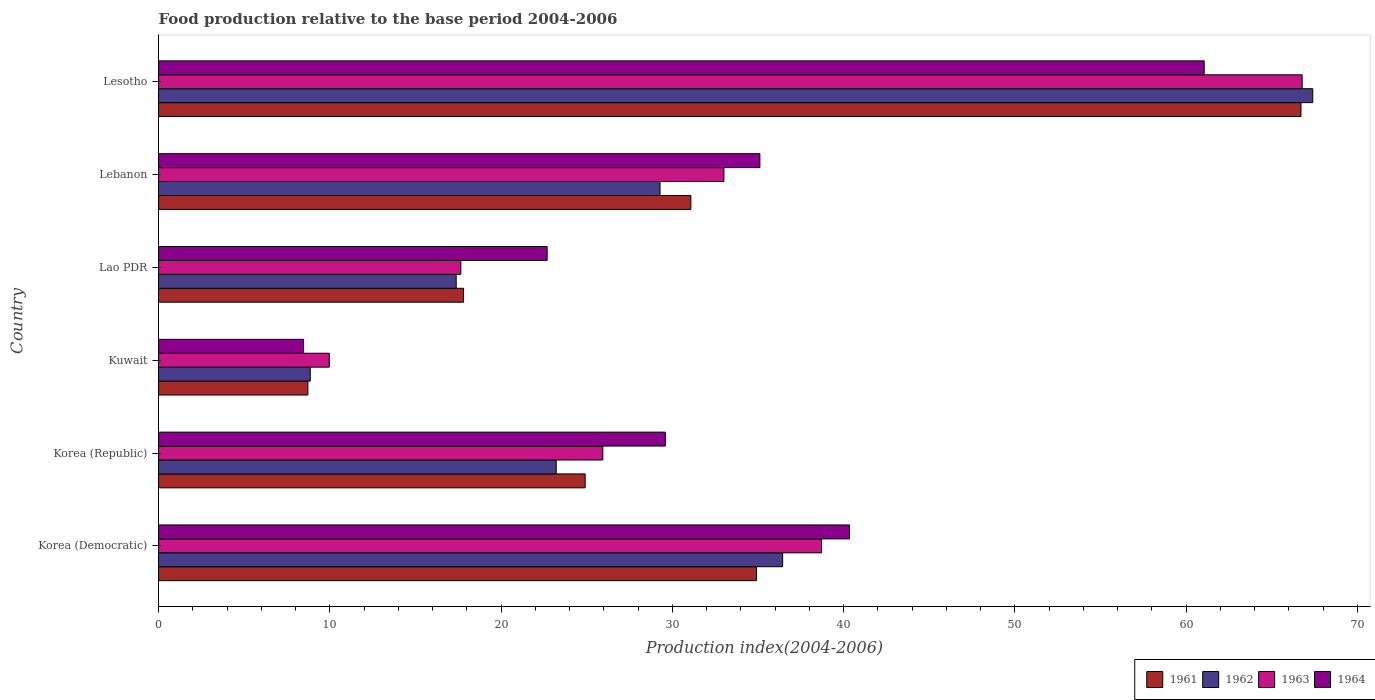How many different coloured bars are there?
Offer a very short reply. 4. How many groups of bars are there?
Your response must be concise. 6. Are the number of bars on each tick of the Y-axis equal?
Give a very brief answer. Yes. What is the label of the 6th group of bars from the top?
Keep it short and to the point. Korea (Democratic). In how many cases, is the number of bars for a given country not equal to the number of legend labels?
Give a very brief answer. 0. What is the food production index in 1962 in Korea (Democratic)?
Keep it short and to the point. 36.44. Across all countries, what is the maximum food production index in 1962?
Provide a succinct answer. 67.39. Across all countries, what is the minimum food production index in 1961?
Provide a short and direct response. 8.72. In which country was the food production index in 1961 maximum?
Give a very brief answer. Lesotho. In which country was the food production index in 1964 minimum?
Your answer should be very brief. Kuwait. What is the total food production index in 1962 in the graph?
Your response must be concise. 182.57. What is the difference between the food production index in 1961 in Korea (Democratic) and that in Lebanon?
Ensure brevity in your answer.  3.83. What is the difference between the food production index in 1963 in Lebanon and the food production index in 1962 in Korea (Republic)?
Your response must be concise. 9.79. What is the average food production index in 1962 per country?
Offer a very short reply. 30.43. What is the difference between the food production index in 1964 and food production index in 1961 in Korea (Democratic)?
Your answer should be compact. 5.43. In how many countries, is the food production index in 1964 greater than 40 ?
Your answer should be very brief. 2. What is the ratio of the food production index in 1961 in Korea (Democratic) to that in Lebanon?
Make the answer very short. 1.12. Is the food production index in 1961 in Korea (Democratic) less than that in Kuwait?
Provide a succinct answer. No. Is the difference between the food production index in 1964 in Korea (Democratic) and Kuwait greater than the difference between the food production index in 1961 in Korea (Democratic) and Kuwait?
Keep it short and to the point. Yes. What is the difference between the highest and the second highest food production index in 1962?
Your answer should be very brief. 30.95. What is the difference between the highest and the lowest food production index in 1964?
Your answer should be very brief. 52.58. Is the sum of the food production index in 1962 in Korea (Democratic) and Kuwait greater than the maximum food production index in 1961 across all countries?
Keep it short and to the point. No. Is it the case that in every country, the sum of the food production index in 1963 and food production index in 1961 is greater than the sum of food production index in 1962 and food production index in 1964?
Provide a succinct answer. No. What does the 3rd bar from the top in Lao PDR represents?
Your answer should be very brief. 1962. What does the 1st bar from the bottom in Korea (Democratic) represents?
Your answer should be compact. 1961. How many bars are there?
Provide a short and direct response. 24. Are all the bars in the graph horizontal?
Offer a terse response. Yes. Are the values on the major ticks of X-axis written in scientific E-notation?
Your answer should be compact. No. Does the graph contain any zero values?
Make the answer very short. No. Where does the legend appear in the graph?
Keep it short and to the point. Bottom right. How are the legend labels stacked?
Keep it short and to the point. Horizontal. What is the title of the graph?
Offer a terse response. Food production relative to the base period 2004-2006. Does "1997" appear as one of the legend labels in the graph?
Your answer should be compact. No. What is the label or title of the X-axis?
Give a very brief answer. Production index(2004-2006). What is the Production index(2004-2006) of 1961 in Korea (Democratic)?
Your response must be concise. 34.91. What is the Production index(2004-2006) in 1962 in Korea (Democratic)?
Your answer should be compact. 36.44. What is the Production index(2004-2006) in 1963 in Korea (Democratic)?
Offer a terse response. 38.71. What is the Production index(2004-2006) of 1964 in Korea (Democratic)?
Your response must be concise. 40.34. What is the Production index(2004-2006) of 1961 in Korea (Republic)?
Your answer should be very brief. 24.91. What is the Production index(2004-2006) in 1962 in Korea (Republic)?
Your response must be concise. 23.22. What is the Production index(2004-2006) of 1963 in Korea (Republic)?
Provide a succinct answer. 25.94. What is the Production index(2004-2006) in 1964 in Korea (Republic)?
Offer a terse response. 29.59. What is the Production index(2004-2006) in 1961 in Kuwait?
Your answer should be very brief. 8.72. What is the Production index(2004-2006) of 1962 in Kuwait?
Provide a short and direct response. 8.86. What is the Production index(2004-2006) of 1963 in Kuwait?
Make the answer very short. 9.97. What is the Production index(2004-2006) in 1964 in Kuwait?
Your answer should be very brief. 8.47. What is the Production index(2004-2006) of 1961 in Lao PDR?
Ensure brevity in your answer.  17.81. What is the Production index(2004-2006) in 1962 in Lao PDR?
Offer a very short reply. 17.38. What is the Production index(2004-2006) of 1963 in Lao PDR?
Offer a very short reply. 17.65. What is the Production index(2004-2006) of 1964 in Lao PDR?
Make the answer very short. 22.69. What is the Production index(2004-2006) in 1961 in Lebanon?
Make the answer very short. 31.08. What is the Production index(2004-2006) of 1962 in Lebanon?
Your answer should be very brief. 29.28. What is the Production index(2004-2006) in 1963 in Lebanon?
Ensure brevity in your answer.  33.01. What is the Production index(2004-2006) of 1964 in Lebanon?
Your answer should be compact. 35.11. What is the Production index(2004-2006) in 1961 in Lesotho?
Ensure brevity in your answer.  66.7. What is the Production index(2004-2006) in 1962 in Lesotho?
Your response must be concise. 67.39. What is the Production index(2004-2006) of 1963 in Lesotho?
Your response must be concise. 66.77. What is the Production index(2004-2006) of 1964 in Lesotho?
Provide a succinct answer. 61.05. Across all countries, what is the maximum Production index(2004-2006) of 1961?
Your answer should be very brief. 66.7. Across all countries, what is the maximum Production index(2004-2006) in 1962?
Make the answer very short. 67.39. Across all countries, what is the maximum Production index(2004-2006) in 1963?
Make the answer very short. 66.77. Across all countries, what is the maximum Production index(2004-2006) in 1964?
Offer a terse response. 61.05. Across all countries, what is the minimum Production index(2004-2006) in 1961?
Your response must be concise. 8.72. Across all countries, what is the minimum Production index(2004-2006) in 1962?
Offer a terse response. 8.86. Across all countries, what is the minimum Production index(2004-2006) in 1963?
Offer a very short reply. 9.97. Across all countries, what is the minimum Production index(2004-2006) in 1964?
Keep it short and to the point. 8.47. What is the total Production index(2004-2006) in 1961 in the graph?
Ensure brevity in your answer.  184.13. What is the total Production index(2004-2006) of 1962 in the graph?
Give a very brief answer. 182.57. What is the total Production index(2004-2006) in 1963 in the graph?
Ensure brevity in your answer.  192.05. What is the total Production index(2004-2006) in 1964 in the graph?
Give a very brief answer. 197.25. What is the difference between the Production index(2004-2006) of 1962 in Korea (Democratic) and that in Korea (Republic)?
Offer a terse response. 13.22. What is the difference between the Production index(2004-2006) in 1963 in Korea (Democratic) and that in Korea (Republic)?
Your answer should be compact. 12.77. What is the difference between the Production index(2004-2006) of 1964 in Korea (Democratic) and that in Korea (Republic)?
Make the answer very short. 10.75. What is the difference between the Production index(2004-2006) of 1961 in Korea (Democratic) and that in Kuwait?
Make the answer very short. 26.19. What is the difference between the Production index(2004-2006) of 1962 in Korea (Democratic) and that in Kuwait?
Keep it short and to the point. 27.58. What is the difference between the Production index(2004-2006) in 1963 in Korea (Democratic) and that in Kuwait?
Your response must be concise. 28.74. What is the difference between the Production index(2004-2006) of 1964 in Korea (Democratic) and that in Kuwait?
Offer a terse response. 31.87. What is the difference between the Production index(2004-2006) in 1962 in Korea (Democratic) and that in Lao PDR?
Offer a very short reply. 19.06. What is the difference between the Production index(2004-2006) in 1963 in Korea (Democratic) and that in Lao PDR?
Offer a terse response. 21.06. What is the difference between the Production index(2004-2006) of 1964 in Korea (Democratic) and that in Lao PDR?
Your response must be concise. 17.65. What is the difference between the Production index(2004-2006) of 1961 in Korea (Democratic) and that in Lebanon?
Provide a succinct answer. 3.83. What is the difference between the Production index(2004-2006) in 1962 in Korea (Democratic) and that in Lebanon?
Offer a very short reply. 7.16. What is the difference between the Production index(2004-2006) of 1963 in Korea (Democratic) and that in Lebanon?
Your answer should be very brief. 5.7. What is the difference between the Production index(2004-2006) in 1964 in Korea (Democratic) and that in Lebanon?
Offer a terse response. 5.23. What is the difference between the Production index(2004-2006) in 1961 in Korea (Democratic) and that in Lesotho?
Your answer should be compact. -31.79. What is the difference between the Production index(2004-2006) in 1962 in Korea (Democratic) and that in Lesotho?
Offer a terse response. -30.95. What is the difference between the Production index(2004-2006) in 1963 in Korea (Democratic) and that in Lesotho?
Offer a terse response. -28.06. What is the difference between the Production index(2004-2006) in 1964 in Korea (Democratic) and that in Lesotho?
Ensure brevity in your answer.  -20.71. What is the difference between the Production index(2004-2006) in 1961 in Korea (Republic) and that in Kuwait?
Offer a terse response. 16.19. What is the difference between the Production index(2004-2006) of 1962 in Korea (Republic) and that in Kuwait?
Ensure brevity in your answer.  14.36. What is the difference between the Production index(2004-2006) of 1963 in Korea (Republic) and that in Kuwait?
Make the answer very short. 15.97. What is the difference between the Production index(2004-2006) of 1964 in Korea (Republic) and that in Kuwait?
Your answer should be compact. 21.12. What is the difference between the Production index(2004-2006) in 1962 in Korea (Republic) and that in Lao PDR?
Offer a very short reply. 5.84. What is the difference between the Production index(2004-2006) of 1963 in Korea (Republic) and that in Lao PDR?
Your answer should be compact. 8.29. What is the difference between the Production index(2004-2006) in 1964 in Korea (Republic) and that in Lao PDR?
Provide a succinct answer. 6.9. What is the difference between the Production index(2004-2006) of 1961 in Korea (Republic) and that in Lebanon?
Make the answer very short. -6.17. What is the difference between the Production index(2004-2006) in 1962 in Korea (Republic) and that in Lebanon?
Provide a succinct answer. -6.06. What is the difference between the Production index(2004-2006) of 1963 in Korea (Republic) and that in Lebanon?
Give a very brief answer. -7.07. What is the difference between the Production index(2004-2006) of 1964 in Korea (Republic) and that in Lebanon?
Give a very brief answer. -5.52. What is the difference between the Production index(2004-2006) in 1961 in Korea (Republic) and that in Lesotho?
Ensure brevity in your answer.  -41.79. What is the difference between the Production index(2004-2006) in 1962 in Korea (Republic) and that in Lesotho?
Your response must be concise. -44.17. What is the difference between the Production index(2004-2006) in 1963 in Korea (Republic) and that in Lesotho?
Your answer should be very brief. -40.83. What is the difference between the Production index(2004-2006) of 1964 in Korea (Republic) and that in Lesotho?
Provide a succinct answer. -31.46. What is the difference between the Production index(2004-2006) of 1961 in Kuwait and that in Lao PDR?
Offer a very short reply. -9.09. What is the difference between the Production index(2004-2006) in 1962 in Kuwait and that in Lao PDR?
Your answer should be compact. -8.52. What is the difference between the Production index(2004-2006) of 1963 in Kuwait and that in Lao PDR?
Provide a succinct answer. -7.68. What is the difference between the Production index(2004-2006) of 1964 in Kuwait and that in Lao PDR?
Your answer should be compact. -14.22. What is the difference between the Production index(2004-2006) in 1961 in Kuwait and that in Lebanon?
Give a very brief answer. -22.36. What is the difference between the Production index(2004-2006) of 1962 in Kuwait and that in Lebanon?
Provide a succinct answer. -20.42. What is the difference between the Production index(2004-2006) of 1963 in Kuwait and that in Lebanon?
Provide a succinct answer. -23.04. What is the difference between the Production index(2004-2006) of 1964 in Kuwait and that in Lebanon?
Offer a terse response. -26.64. What is the difference between the Production index(2004-2006) of 1961 in Kuwait and that in Lesotho?
Provide a succinct answer. -57.98. What is the difference between the Production index(2004-2006) in 1962 in Kuwait and that in Lesotho?
Keep it short and to the point. -58.53. What is the difference between the Production index(2004-2006) of 1963 in Kuwait and that in Lesotho?
Provide a short and direct response. -56.8. What is the difference between the Production index(2004-2006) in 1964 in Kuwait and that in Lesotho?
Provide a short and direct response. -52.58. What is the difference between the Production index(2004-2006) of 1961 in Lao PDR and that in Lebanon?
Provide a succinct answer. -13.27. What is the difference between the Production index(2004-2006) in 1962 in Lao PDR and that in Lebanon?
Offer a very short reply. -11.9. What is the difference between the Production index(2004-2006) in 1963 in Lao PDR and that in Lebanon?
Offer a very short reply. -15.36. What is the difference between the Production index(2004-2006) of 1964 in Lao PDR and that in Lebanon?
Give a very brief answer. -12.42. What is the difference between the Production index(2004-2006) in 1961 in Lao PDR and that in Lesotho?
Your response must be concise. -48.89. What is the difference between the Production index(2004-2006) in 1962 in Lao PDR and that in Lesotho?
Your answer should be very brief. -50.01. What is the difference between the Production index(2004-2006) of 1963 in Lao PDR and that in Lesotho?
Ensure brevity in your answer.  -49.12. What is the difference between the Production index(2004-2006) in 1964 in Lao PDR and that in Lesotho?
Give a very brief answer. -38.36. What is the difference between the Production index(2004-2006) of 1961 in Lebanon and that in Lesotho?
Give a very brief answer. -35.62. What is the difference between the Production index(2004-2006) in 1962 in Lebanon and that in Lesotho?
Keep it short and to the point. -38.11. What is the difference between the Production index(2004-2006) of 1963 in Lebanon and that in Lesotho?
Your answer should be very brief. -33.76. What is the difference between the Production index(2004-2006) of 1964 in Lebanon and that in Lesotho?
Keep it short and to the point. -25.94. What is the difference between the Production index(2004-2006) of 1961 in Korea (Democratic) and the Production index(2004-2006) of 1962 in Korea (Republic)?
Your answer should be compact. 11.69. What is the difference between the Production index(2004-2006) of 1961 in Korea (Democratic) and the Production index(2004-2006) of 1963 in Korea (Republic)?
Provide a short and direct response. 8.97. What is the difference between the Production index(2004-2006) in 1961 in Korea (Democratic) and the Production index(2004-2006) in 1964 in Korea (Republic)?
Offer a very short reply. 5.32. What is the difference between the Production index(2004-2006) of 1962 in Korea (Democratic) and the Production index(2004-2006) of 1964 in Korea (Republic)?
Give a very brief answer. 6.85. What is the difference between the Production index(2004-2006) of 1963 in Korea (Democratic) and the Production index(2004-2006) of 1964 in Korea (Republic)?
Offer a very short reply. 9.12. What is the difference between the Production index(2004-2006) of 1961 in Korea (Democratic) and the Production index(2004-2006) of 1962 in Kuwait?
Make the answer very short. 26.05. What is the difference between the Production index(2004-2006) in 1961 in Korea (Democratic) and the Production index(2004-2006) in 1963 in Kuwait?
Ensure brevity in your answer.  24.94. What is the difference between the Production index(2004-2006) of 1961 in Korea (Democratic) and the Production index(2004-2006) of 1964 in Kuwait?
Your answer should be compact. 26.44. What is the difference between the Production index(2004-2006) of 1962 in Korea (Democratic) and the Production index(2004-2006) of 1963 in Kuwait?
Your answer should be compact. 26.47. What is the difference between the Production index(2004-2006) in 1962 in Korea (Democratic) and the Production index(2004-2006) in 1964 in Kuwait?
Keep it short and to the point. 27.97. What is the difference between the Production index(2004-2006) of 1963 in Korea (Democratic) and the Production index(2004-2006) of 1964 in Kuwait?
Your response must be concise. 30.24. What is the difference between the Production index(2004-2006) in 1961 in Korea (Democratic) and the Production index(2004-2006) in 1962 in Lao PDR?
Your response must be concise. 17.53. What is the difference between the Production index(2004-2006) of 1961 in Korea (Democratic) and the Production index(2004-2006) of 1963 in Lao PDR?
Make the answer very short. 17.26. What is the difference between the Production index(2004-2006) in 1961 in Korea (Democratic) and the Production index(2004-2006) in 1964 in Lao PDR?
Provide a short and direct response. 12.22. What is the difference between the Production index(2004-2006) in 1962 in Korea (Democratic) and the Production index(2004-2006) in 1963 in Lao PDR?
Give a very brief answer. 18.79. What is the difference between the Production index(2004-2006) in 1962 in Korea (Democratic) and the Production index(2004-2006) in 1964 in Lao PDR?
Offer a terse response. 13.75. What is the difference between the Production index(2004-2006) in 1963 in Korea (Democratic) and the Production index(2004-2006) in 1964 in Lao PDR?
Make the answer very short. 16.02. What is the difference between the Production index(2004-2006) of 1961 in Korea (Democratic) and the Production index(2004-2006) of 1962 in Lebanon?
Offer a terse response. 5.63. What is the difference between the Production index(2004-2006) in 1961 in Korea (Democratic) and the Production index(2004-2006) in 1963 in Lebanon?
Your answer should be compact. 1.9. What is the difference between the Production index(2004-2006) in 1961 in Korea (Democratic) and the Production index(2004-2006) in 1964 in Lebanon?
Provide a succinct answer. -0.2. What is the difference between the Production index(2004-2006) of 1962 in Korea (Democratic) and the Production index(2004-2006) of 1963 in Lebanon?
Offer a terse response. 3.43. What is the difference between the Production index(2004-2006) of 1962 in Korea (Democratic) and the Production index(2004-2006) of 1964 in Lebanon?
Ensure brevity in your answer.  1.33. What is the difference between the Production index(2004-2006) in 1961 in Korea (Democratic) and the Production index(2004-2006) in 1962 in Lesotho?
Your answer should be very brief. -32.48. What is the difference between the Production index(2004-2006) in 1961 in Korea (Democratic) and the Production index(2004-2006) in 1963 in Lesotho?
Keep it short and to the point. -31.86. What is the difference between the Production index(2004-2006) of 1961 in Korea (Democratic) and the Production index(2004-2006) of 1964 in Lesotho?
Provide a succinct answer. -26.14. What is the difference between the Production index(2004-2006) in 1962 in Korea (Democratic) and the Production index(2004-2006) in 1963 in Lesotho?
Offer a terse response. -30.33. What is the difference between the Production index(2004-2006) in 1962 in Korea (Democratic) and the Production index(2004-2006) in 1964 in Lesotho?
Ensure brevity in your answer.  -24.61. What is the difference between the Production index(2004-2006) of 1963 in Korea (Democratic) and the Production index(2004-2006) of 1964 in Lesotho?
Offer a very short reply. -22.34. What is the difference between the Production index(2004-2006) of 1961 in Korea (Republic) and the Production index(2004-2006) of 1962 in Kuwait?
Offer a very short reply. 16.05. What is the difference between the Production index(2004-2006) of 1961 in Korea (Republic) and the Production index(2004-2006) of 1963 in Kuwait?
Your response must be concise. 14.94. What is the difference between the Production index(2004-2006) of 1961 in Korea (Republic) and the Production index(2004-2006) of 1964 in Kuwait?
Provide a short and direct response. 16.44. What is the difference between the Production index(2004-2006) of 1962 in Korea (Republic) and the Production index(2004-2006) of 1963 in Kuwait?
Provide a succinct answer. 13.25. What is the difference between the Production index(2004-2006) in 1962 in Korea (Republic) and the Production index(2004-2006) in 1964 in Kuwait?
Offer a very short reply. 14.75. What is the difference between the Production index(2004-2006) in 1963 in Korea (Republic) and the Production index(2004-2006) in 1964 in Kuwait?
Offer a very short reply. 17.47. What is the difference between the Production index(2004-2006) of 1961 in Korea (Republic) and the Production index(2004-2006) of 1962 in Lao PDR?
Offer a very short reply. 7.53. What is the difference between the Production index(2004-2006) of 1961 in Korea (Republic) and the Production index(2004-2006) of 1963 in Lao PDR?
Keep it short and to the point. 7.26. What is the difference between the Production index(2004-2006) in 1961 in Korea (Republic) and the Production index(2004-2006) in 1964 in Lao PDR?
Your answer should be compact. 2.22. What is the difference between the Production index(2004-2006) in 1962 in Korea (Republic) and the Production index(2004-2006) in 1963 in Lao PDR?
Make the answer very short. 5.57. What is the difference between the Production index(2004-2006) of 1962 in Korea (Republic) and the Production index(2004-2006) of 1964 in Lao PDR?
Ensure brevity in your answer.  0.53. What is the difference between the Production index(2004-2006) in 1963 in Korea (Republic) and the Production index(2004-2006) in 1964 in Lao PDR?
Ensure brevity in your answer.  3.25. What is the difference between the Production index(2004-2006) of 1961 in Korea (Republic) and the Production index(2004-2006) of 1962 in Lebanon?
Your answer should be very brief. -4.37. What is the difference between the Production index(2004-2006) in 1962 in Korea (Republic) and the Production index(2004-2006) in 1963 in Lebanon?
Your answer should be compact. -9.79. What is the difference between the Production index(2004-2006) of 1962 in Korea (Republic) and the Production index(2004-2006) of 1964 in Lebanon?
Your answer should be very brief. -11.89. What is the difference between the Production index(2004-2006) in 1963 in Korea (Republic) and the Production index(2004-2006) in 1964 in Lebanon?
Keep it short and to the point. -9.17. What is the difference between the Production index(2004-2006) in 1961 in Korea (Republic) and the Production index(2004-2006) in 1962 in Lesotho?
Provide a succinct answer. -42.48. What is the difference between the Production index(2004-2006) in 1961 in Korea (Republic) and the Production index(2004-2006) in 1963 in Lesotho?
Give a very brief answer. -41.86. What is the difference between the Production index(2004-2006) in 1961 in Korea (Republic) and the Production index(2004-2006) in 1964 in Lesotho?
Your answer should be very brief. -36.14. What is the difference between the Production index(2004-2006) of 1962 in Korea (Republic) and the Production index(2004-2006) of 1963 in Lesotho?
Keep it short and to the point. -43.55. What is the difference between the Production index(2004-2006) in 1962 in Korea (Republic) and the Production index(2004-2006) in 1964 in Lesotho?
Offer a very short reply. -37.83. What is the difference between the Production index(2004-2006) of 1963 in Korea (Republic) and the Production index(2004-2006) of 1964 in Lesotho?
Provide a short and direct response. -35.11. What is the difference between the Production index(2004-2006) in 1961 in Kuwait and the Production index(2004-2006) in 1962 in Lao PDR?
Provide a succinct answer. -8.66. What is the difference between the Production index(2004-2006) of 1961 in Kuwait and the Production index(2004-2006) of 1963 in Lao PDR?
Your response must be concise. -8.93. What is the difference between the Production index(2004-2006) in 1961 in Kuwait and the Production index(2004-2006) in 1964 in Lao PDR?
Give a very brief answer. -13.97. What is the difference between the Production index(2004-2006) of 1962 in Kuwait and the Production index(2004-2006) of 1963 in Lao PDR?
Keep it short and to the point. -8.79. What is the difference between the Production index(2004-2006) in 1962 in Kuwait and the Production index(2004-2006) in 1964 in Lao PDR?
Your answer should be very brief. -13.83. What is the difference between the Production index(2004-2006) in 1963 in Kuwait and the Production index(2004-2006) in 1964 in Lao PDR?
Your answer should be very brief. -12.72. What is the difference between the Production index(2004-2006) in 1961 in Kuwait and the Production index(2004-2006) in 1962 in Lebanon?
Keep it short and to the point. -20.56. What is the difference between the Production index(2004-2006) in 1961 in Kuwait and the Production index(2004-2006) in 1963 in Lebanon?
Your response must be concise. -24.29. What is the difference between the Production index(2004-2006) in 1961 in Kuwait and the Production index(2004-2006) in 1964 in Lebanon?
Offer a terse response. -26.39. What is the difference between the Production index(2004-2006) in 1962 in Kuwait and the Production index(2004-2006) in 1963 in Lebanon?
Give a very brief answer. -24.15. What is the difference between the Production index(2004-2006) of 1962 in Kuwait and the Production index(2004-2006) of 1964 in Lebanon?
Give a very brief answer. -26.25. What is the difference between the Production index(2004-2006) of 1963 in Kuwait and the Production index(2004-2006) of 1964 in Lebanon?
Offer a terse response. -25.14. What is the difference between the Production index(2004-2006) of 1961 in Kuwait and the Production index(2004-2006) of 1962 in Lesotho?
Your response must be concise. -58.67. What is the difference between the Production index(2004-2006) in 1961 in Kuwait and the Production index(2004-2006) in 1963 in Lesotho?
Keep it short and to the point. -58.05. What is the difference between the Production index(2004-2006) of 1961 in Kuwait and the Production index(2004-2006) of 1964 in Lesotho?
Your response must be concise. -52.33. What is the difference between the Production index(2004-2006) in 1962 in Kuwait and the Production index(2004-2006) in 1963 in Lesotho?
Offer a very short reply. -57.91. What is the difference between the Production index(2004-2006) of 1962 in Kuwait and the Production index(2004-2006) of 1964 in Lesotho?
Offer a terse response. -52.19. What is the difference between the Production index(2004-2006) in 1963 in Kuwait and the Production index(2004-2006) in 1964 in Lesotho?
Provide a short and direct response. -51.08. What is the difference between the Production index(2004-2006) in 1961 in Lao PDR and the Production index(2004-2006) in 1962 in Lebanon?
Ensure brevity in your answer.  -11.47. What is the difference between the Production index(2004-2006) of 1961 in Lao PDR and the Production index(2004-2006) of 1963 in Lebanon?
Offer a very short reply. -15.2. What is the difference between the Production index(2004-2006) of 1961 in Lao PDR and the Production index(2004-2006) of 1964 in Lebanon?
Keep it short and to the point. -17.3. What is the difference between the Production index(2004-2006) of 1962 in Lao PDR and the Production index(2004-2006) of 1963 in Lebanon?
Your answer should be compact. -15.63. What is the difference between the Production index(2004-2006) in 1962 in Lao PDR and the Production index(2004-2006) in 1964 in Lebanon?
Your answer should be very brief. -17.73. What is the difference between the Production index(2004-2006) of 1963 in Lao PDR and the Production index(2004-2006) of 1964 in Lebanon?
Give a very brief answer. -17.46. What is the difference between the Production index(2004-2006) of 1961 in Lao PDR and the Production index(2004-2006) of 1962 in Lesotho?
Provide a short and direct response. -49.58. What is the difference between the Production index(2004-2006) of 1961 in Lao PDR and the Production index(2004-2006) of 1963 in Lesotho?
Your answer should be very brief. -48.96. What is the difference between the Production index(2004-2006) in 1961 in Lao PDR and the Production index(2004-2006) in 1964 in Lesotho?
Give a very brief answer. -43.24. What is the difference between the Production index(2004-2006) of 1962 in Lao PDR and the Production index(2004-2006) of 1963 in Lesotho?
Offer a very short reply. -49.39. What is the difference between the Production index(2004-2006) of 1962 in Lao PDR and the Production index(2004-2006) of 1964 in Lesotho?
Offer a very short reply. -43.67. What is the difference between the Production index(2004-2006) in 1963 in Lao PDR and the Production index(2004-2006) in 1964 in Lesotho?
Your response must be concise. -43.4. What is the difference between the Production index(2004-2006) of 1961 in Lebanon and the Production index(2004-2006) of 1962 in Lesotho?
Make the answer very short. -36.31. What is the difference between the Production index(2004-2006) of 1961 in Lebanon and the Production index(2004-2006) of 1963 in Lesotho?
Make the answer very short. -35.69. What is the difference between the Production index(2004-2006) in 1961 in Lebanon and the Production index(2004-2006) in 1964 in Lesotho?
Keep it short and to the point. -29.97. What is the difference between the Production index(2004-2006) in 1962 in Lebanon and the Production index(2004-2006) in 1963 in Lesotho?
Your answer should be compact. -37.49. What is the difference between the Production index(2004-2006) in 1962 in Lebanon and the Production index(2004-2006) in 1964 in Lesotho?
Offer a very short reply. -31.77. What is the difference between the Production index(2004-2006) of 1963 in Lebanon and the Production index(2004-2006) of 1964 in Lesotho?
Provide a short and direct response. -28.04. What is the average Production index(2004-2006) of 1961 per country?
Make the answer very short. 30.69. What is the average Production index(2004-2006) of 1962 per country?
Make the answer very short. 30.43. What is the average Production index(2004-2006) of 1963 per country?
Make the answer very short. 32.01. What is the average Production index(2004-2006) of 1964 per country?
Offer a very short reply. 32.88. What is the difference between the Production index(2004-2006) in 1961 and Production index(2004-2006) in 1962 in Korea (Democratic)?
Offer a terse response. -1.53. What is the difference between the Production index(2004-2006) of 1961 and Production index(2004-2006) of 1963 in Korea (Democratic)?
Keep it short and to the point. -3.8. What is the difference between the Production index(2004-2006) in 1961 and Production index(2004-2006) in 1964 in Korea (Democratic)?
Your answer should be very brief. -5.43. What is the difference between the Production index(2004-2006) of 1962 and Production index(2004-2006) of 1963 in Korea (Democratic)?
Your answer should be compact. -2.27. What is the difference between the Production index(2004-2006) in 1963 and Production index(2004-2006) in 1964 in Korea (Democratic)?
Offer a very short reply. -1.63. What is the difference between the Production index(2004-2006) in 1961 and Production index(2004-2006) in 1962 in Korea (Republic)?
Your response must be concise. 1.69. What is the difference between the Production index(2004-2006) in 1961 and Production index(2004-2006) in 1963 in Korea (Republic)?
Keep it short and to the point. -1.03. What is the difference between the Production index(2004-2006) in 1961 and Production index(2004-2006) in 1964 in Korea (Republic)?
Give a very brief answer. -4.68. What is the difference between the Production index(2004-2006) in 1962 and Production index(2004-2006) in 1963 in Korea (Republic)?
Ensure brevity in your answer.  -2.72. What is the difference between the Production index(2004-2006) of 1962 and Production index(2004-2006) of 1964 in Korea (Republic)?
Offer a very short reply. -6.37. What is the difference between the Production index(2004-2006) of 1963 and Production index(2004-2006) of 1964 in Korea (Republic)?
Your answer should be compact. -3.65. What is the difference between the Production index(2004-2006) of 1961 and Production index(2004-2006) of 1962 in Kuwait?
Your response must be concise. -0.14. What is the difference between the Production index(2004-2006) of 1961 and Production index(2004-2006) of 1963 in Kuwait?
Provide a succinct answer. -1.25. What is the difference between the Production index(2004-2006) in 1961 and Production index(2004-2006) in 1964 in Kuwait?
Make the answer very short. 0.25. What is the difference between the Production index(2004-2006) of 1962 and Production index(2004-2006) of 1963 in Kuwait?
Provide a succinct answer. -1.11. What is the difference between the Production index(2004-2006) in 1962 and Production index(2004-2006) in 1964 in Kuwait?
Your answer should be compact. 0.39. What is the difference between the Production index(2004-2006) in 1963 and Production index(2004-2006) in 1964 in Kuwait?
Provide a succinct answer. 1.5. What is the difference between the Production index(2004-2006) of 1961 and Production index(2004-2006) of 1962 in Lao PDR?
Keep it short and to the point. 0.43. What is the difference between the Production index(2004-2006) of 1961 and Production index(2004-2006) of 1963 in Lao PDR?
Offer a very short reply. 0.16. What is the difference between the Production index(2004-2006) of 1961 and Production index(2004-2006) of 1964 in Lao PDR?
Your answer should be very brief. -4.88. What is the difference between the Production index(2004-2006) in 1962 and Production index(2004-2006) in 1963 in Lao PDR?
Your response must be concise. -0.27. What is the difference between the Production index(2004-2006) of 1962 and Production index(2004-2006) of 1964 in Lao PDR?
Ensure brevity in your answer.  -5.31. What is the difference between the Production index(2004-2006) in 1963 and Production index(2004-2006) in 1964 in Lao PDR?
Your answer should be very brief. -5.04. What is the difference between the Production index(2004-2006) in 1961 and Production index(2004-2006) in 1963 in Lebanon?
Give a very brief answer. -1.93. What is the difference between the Production index(2004-2006) of 1961 and Production index(2004-2006) of 1964 in Lebanon?
Give a very brief answer. -4.03. What is the difference between the Production index(2004-2006) of 1962 and Production index(2004-2006) of 1963 in Lebanon?
Your answer should be very brief. -3.73. What is the difference between the Production index(2004-2006) in 1962 and Production index(2004-2006) in 1964 in Lebanon?
Offer a terse response. -5.83. What is the difference between the Production index(2004-2006) in 1963 and Production index(2004-2006) in 1964 in Lebanon?
Provide a short and direct response. -2.1. What is the difference between the Production index(2004-2006) in 1961 and Production index(2004-2006) in 1962 in Lesotho?
Ensure brevity in your answer.  -0.69. What is the difference between the Production index(2004-2006) in 1961 and Production index(2004-2006) in 1963 in Lesotho?
Your response must be concise. -0.07. What is the difference between the Production index(2004-2006) in 1961 and Production index(2004-2006) in 1964 in Lesotho?
Offer a very short reply. 5.65. What is the difference between the Production index(2004-2006) of 1962 and Production index(2004-2006) of 1963 in Lesotho?
Your answer should be compact. 0.62. What is the difference between the Production index(2004-2006) in 1962 and Production index(2004-2006) in 1964 in Lesotho?
Provide a succinct answer. 6.34. What is the difference between the Production index(2004-2006) of 1963 and Production index(2004-2006) of 1964 in Lesotho?
Provide a short and direct response. 5.72. What is the ratio of the Production index(2004-2006) in 1961 in Korea (Democratic) to that in Korea (Republic)?
Provide a succinct answer. 1.4. What is the ratio of the Production index(2004-2006) in 1962 in Korea (Democratic) to that in Korea (Republic)?
Provide a succinct answer. 1.57. What is the ratio of the Production index(2004-2006) of 1963 in Korea (Democratic) to that in Korea (Republic)?
Ensure brevity in your answer.  1.49. What is the ratio of the Production index(2004-2006) of 1964 in Korea (Democratic) to that in Korea (Republic)?
Your answer should be compact. 1.36. What is the ratio of the Production index(2004-2006) of 1961 in Korea (Democratic) to that in Kuwait?
Your response must be concise. 4. What is the ratio of the Production index(2004-2006) of 1962 in Korea (Democratic) to that in Kuwait?
Your answer should be very brief. 4.11. What is the ratio of the Production index(2004-2006) in 1963 in Korea (Democratic) to that in Kuwait?
Make the answer very short. 3.88. What is the ratio of the Production index(2004-2006) of 1964 in Korea (Democratic) to that in Kuwait?
Offer a very short reply. 4.76. What is the ratio of the Production index(2004-2006) in 1961 in Korea (Democratic) to that in Lao PDR?
Your answer should be compact. 1.96. What is the ratio of the Production index(2004-2006) in 1962 in Korea (Democratic) to that in Lao PDR?
Offer a very short reply. 2.1. What is the ratio of the Production index(2004-2006) of 1963 in Korea (Democratic) to that in Lao PDR?
Keep it short and to the point. 2.19. What is the ratio of the Production index(2004-2006) in 1964 in Korea (Democratic) to that in Lao PDR?
Your answer should be compact. 1.78. What is the ratio of the Production index(2004-2006) of 1961 in Korea (Democratic) to that in Lebanon?
Provide a short and direct response. 1.12. What is the ratio of the Production index(2004-2006) in 1962 in Korea (Democratic) to that in Lebanon?
Provide a succinct answer. 1.24. What is the ratio of the Production index(2004-2006) in 1963 in Korea (Democratic) to that in Lebanon?
Your response must be concise. 1.17. What is the ratio of the Production index(2004-2006) in 1964 in Korea (Democratic) to that in Lebanon?
Provide a short and direct response. 1.15. What is the ratio of the Production index(2004-2006) in 1961 in Korea (Democratic) to that in Lesotho?
Offer a terse response. 0.52. What is the ratio of the Production index(2004-2006) of 1962 in Korea (Democratic) to that in Lesotho?
Your answer should be very brief. 0.54. What is the ratio of the Production index(2004-2006) of 1963 in Korea (Democratic) to that in Lesotho?
Your answer should be very brief. 0.58. What is the ratio of the Production index(2004-2006) of 1964 in Korea (Democratic) to that in Lesotho?
Offer a very short reply. 0.66. What is the ratio of the Production index(2004-2006) in 1961 in Korea (Republic) to that in Kuwait?
Ensure brevity in your answer.  2.86. What is the ratio of the Production index(2004-2006) of 1962 in Korea (Republic) to that in Kuwait?
Provide a short and direct response. 2.62. What is the ratio of the Production index(2004-2006) of 1963 in Korea (Republic) to that in Kuwait?
Offer a very short reply. 2.6. What is the ratio of the Production index(2004-2006) of 1964 in Korea (Republic) to that in Kuwait?
Your response must be concise. 3.49. What is the ratio of the Production index(2004-2006) in 1961 in Korea (Republic) to that in Lao PDR?
Ensure brevity in your answer.  1.4. What is the ratio of the Production index(2004-2006) in 1962 in Korea (Republic) to that in Lao PDR?
Your response must be concise. 1.34. What is the ratio of the Production index(2004-2006) of 1963 in Korea (Republic) to that in Lao PDR?
Your response must be concise. 1.47. What is the ratio of the Production index(2004-2006) of 1964 in Korea (Republic) to that in Lao PDR?
Provide a succinct answer. 1.3. What is the ratio of the Production index(2004-2006) in 1961 in Korea (Republic) to that in Lebanon?
Your answer should be compact. 0.8. What is the ratio of the Production index(2004-2006) in 1962 in Korea (Republic) to that in Lebanon?
Provide a succinct answer. 0.79. What is the ratio of the Production index(2004-2006) in 1963 in Korea (Republic) to that in Lebanon?
Your response must be concise. 0.79. What is the ratio of the Production index(2004-2006) in 1964 in Korea (Republic) to that in Lebanon?
Your answer should be compact. 0.84. What is the ratio of the Production index(2004-2006) of 1961 in Korea (Republic) to that in Lesotho?
Keep it short and to the point. 0.37. What is the ratio of the Production index(2004-2006) of 1962 in Korea (Republic) to that in Lesotho?
Provide a succinct answer. 0.34. What is the ratio of the Production index(2004-2006) in 1963 in Korea (Republic) to that in Lesotho?
Offer a very short reply. 0.39. What is the ratio of the Production index(2004-2006) of 1964 in Korea (Republic) to that in Lesotho?
Make the answer very short. 0.48. What is the ratio of the Production index(2004-2006) in 1961 in Kuwait to that in Lao PDR?
Provide a succinct answer. 0.49. What is the ratio of the Production index(2004-2006) of 1962 in Kuwait to that in Lao PDR?
Provide a short and direct response. 0.51. What is the ratio of the Production index(2004-2006) in 1963 in Kuwait to that in Lao PDR?
Your response must be concise. 0.56. What is the ratio of the Production index(2004-2006) of 1964 in Kuwait to that in Lao PDR?
Provide a succinct answer. 0.37. What is the ratio of the Production index(2004-2006) of 1961 in Kuwait to that in Lebanon?
Provide a succinct answer. 0.28. What is the ratio of the Production index(2004-2006) in 1962 in Kuwait to that in Lebanon?
Ensure brevity in your answer.  0.3. What is the ratio of the Production index(2004-2006) of 1963 in Kuwait to that in Lebanon?
Offer a very short reply. 0.3. What is the ratio of the Production index(2004-2006) of 1964 in Kuwait to that in Lebanon?
Give a very brief answer. 0.24. What is the ratio of the Production index(2004-2006) of 1961 in Kuwait to that in Lesotho?
Your response must be concise. 0.13. What is the ratio of the Production index(2004-2006) of 1962 in Kuwait to that in Lesotho?
Your response must be concise. 0.13. What is the ratio of the Production index(2004-2006) in 1963 in Kuwait to that in Lesotho?
Your response must be concise. 0.15. What is the ratio of the Production index(2004-2006) in 1964 in Kuwait to that in Lesotho?
Your response must be concise. 0.14. What is the ratio of the Production index(2004-2006) of 1961 in Lao PDR to that in Lebanon?
Your answer should be very brief. 0.57. What is the ratio of the Production index(2004-2006) in 1962 in Lao PDR to that in Lebanon?
Your answer should be very brief. 0.59. What is the ratio of the Production index(2004-2006) in 1963 in Lao PDR to that in Lebanon?
Make the answer very short. 0.53. What is the ratio of the Production index(2004-2006) of 1964 in Lao PDR to that in Lebanon?
Your answer should be very brief. 0.65. What is the ratio of the Production index(2004-2006) in 1961 in Lao PDR to that in Lesotho?
Your answer should be very brief. 0.27. What is the ratio of the Production index(2004-2006) of 1962 in Lao PDR to that in Lesotho?
Keep it short and to the point. 0.26. What is the ratio of the Production index(2004-2006) in 1963 in Lao PDR to that in Lesotho?
Your response must be concise. 0.26. What is the ratio of the Production index(2004-2006) of 1964 in Lao PDR to that in Lesotho?
Provide a succinct answer. 0.37. What is the ratio of the Production index(2004-2006) in 1961 in Lebanon to that in Lesotho?
Your answer should be very brief. 0.47. What is the ratio of the Production index(2004-2006) of 1962 in Lebanon to that in Lesotho?
Provide a succinct answer. 0.43. What is the ratio of the Production index(2004-2006) in 1963 in Lebanon to that in Lesotho?
Keep it short and to the point. 0.49. What is the ratio of the Production index(2004-2006) of 1964 in Lebanon to that in Lesotho?
Offer a terse response. 0.58. What is the difference between the highest and the second highest Production index(2004-2006) in 1961?
Offer a terse response. 31.79. What is the difference between the highest and the second highest Production index(2004-2006) of 1962?
Give a very brief answer. 30.95. What is the difference between the highest and the second highest Production index(2004-2006) of 1963?
Your answer should be compact. 28.06. What is the difference between the highest and the second highest Production index(2004-2006) in 1964?
Your answer should be very brief. 20.71. What is the difference between the highest and the lowest Production index(2004-2006) in 1961?
Your response must be concise. 57.98. What is the difference between the highest and the lowest Production index(2004-2006) in 1962?
Your answer should be compact. 58.53. What is the difference between the highest and the lowest Production index(2004-2006) in 1963?
Ensure brevity in your answer.  56.8. What is the difference between the highest and the lowest Production index(2004-2006) in 1964?
Keep it short and to the point. 52.58. 